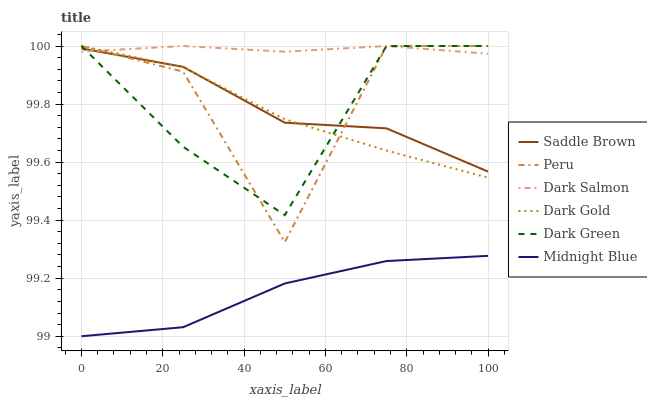Does Midnight Blue have the minimum area under the curve?
Answer yes or no. Yes. Does Dark Salmon have the maximum area under the curve?
Answer yes or no. Yes. Does Dark Gold have the minimum area under the curve?
Answer yes or no. No. Does Dark Gold have the maximum area under the curve?
Answer yes or no. No. Is Dark Salmon the smoothest?
Answer yes or no. Yes. Is Peru the roughest?
Answer yes or no. Yes. Is Dark Gold the smoothest?
Answer yes or no. No. Is Dark Gold the roughest?
Answer yes or no. No. Does Midnight Blue have the lowest value?
Answer yes or no. Yes. Does Dark Gold have the lowest value?
Answer yes or no. No. Does Dark Green have the highest value?
Answer yes or no. Yes. Does Saddle Brown have the highest value?
Answer yes or no. No. Is Midnight Blue less than Dark Green?
Answer yes or no. Yes. Is Saddle Brown greater than Midnight Blue?
Answer yes or no. Yes. Does Dark Gold intersect Dark Salmon?
Answer yes or no. Yes. Is Dark Gold less than Dark Salmon?
Answer yes or no. No. Is Dark Gold greater than Dark Salmon?
Answer yes or no. No. Does Midnight Blue intersect Dark Green?
Answer yes or no. No. 